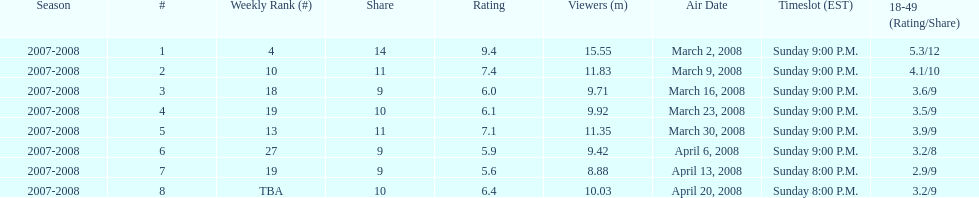What time slot did the show have for its first 6 episodes? Sunday 9:00 P.M. 